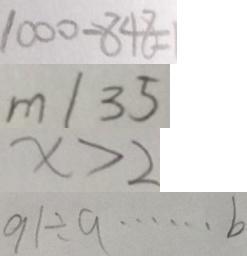Convert formula to latex. <formula><loc_0><loc_0><loc_500><loc_500>1 0 0 0 - 8 4 8 = 1 
 m / 3 5 
 x > 2 
 9 1 \div 9 \cdots b</formula> 